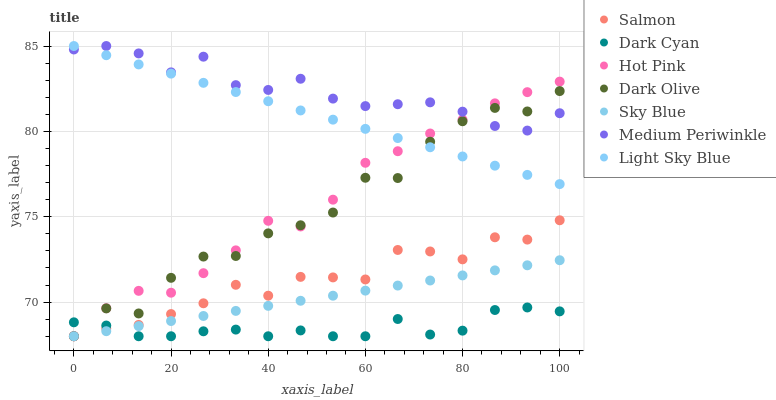Does Dark Cyan have the minimum area under the curve?
Answer yes or no. Yes. Does Medium Periwinkle have the maximum area under the curve?
Answer yes or no. Yes. Does Dark Olive have the minimum area under the curve?
Answer yes or no. No. Does Dark Olive have the maximum area under the curve?
Answer yes or no. No. Is Light Sky Blue the smoothest?
Answer yes or no. Yes. Is Dark Olive the roughest?
Answer yes or no. Yes. Is Medium Periwinkle the smoothest?
Answer yes or no. No. Is Medium Periwinkle the roughest?
Answer yes or no. No. Does Hot Pink have the lowest value?
Answer yes or no. Yes. Does Medium Periwinkle have the lowest value?
Answer yes or no. No. Does Light Sky Blue have the highest value?
Answer yes or no. Yes. Does Dark Olive have the highest value?
Answer yes or no. No. Is Dark Cyan less than Light Sky Blue?
Answer yes or no. Yes. Is Medium Periwinkle greater than Salmon?
Answer yes or no. Yes. Does Medium Periwinkle intersect Dark Olive?
Answer yes or no. Yes. Is Medium Periwinkle less than Dark Olive?
Answer yes or no. No. Is Medium Periwinkle greater than Dark Olive?
Answer yes or no. No. Does Dark Cyan intersect Light Sky Blue?
Answer yes or no. No. 